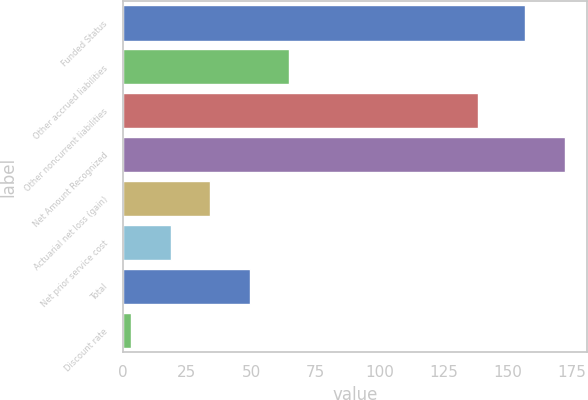Convert chart to OTSL. <chart><loc_0><loc_0><loc_500><loc_500><bar_chart><fcel>Funded Status<fcel>Other accrued liabilities<fcel>Other noncurrent liabilities<fcel>Net Amount Recognized<fcel>Actuarial net loss (gain)<fcel>Net prior service cost<fcel>Total<fcel>Discount rate<nl><fcel>156.9<fcel>64.77<fcel>138.5<fcel>172.26<fcel>34.05<fcel>18.69<fcel>49.41<fcel>3.33<nl></chart> 